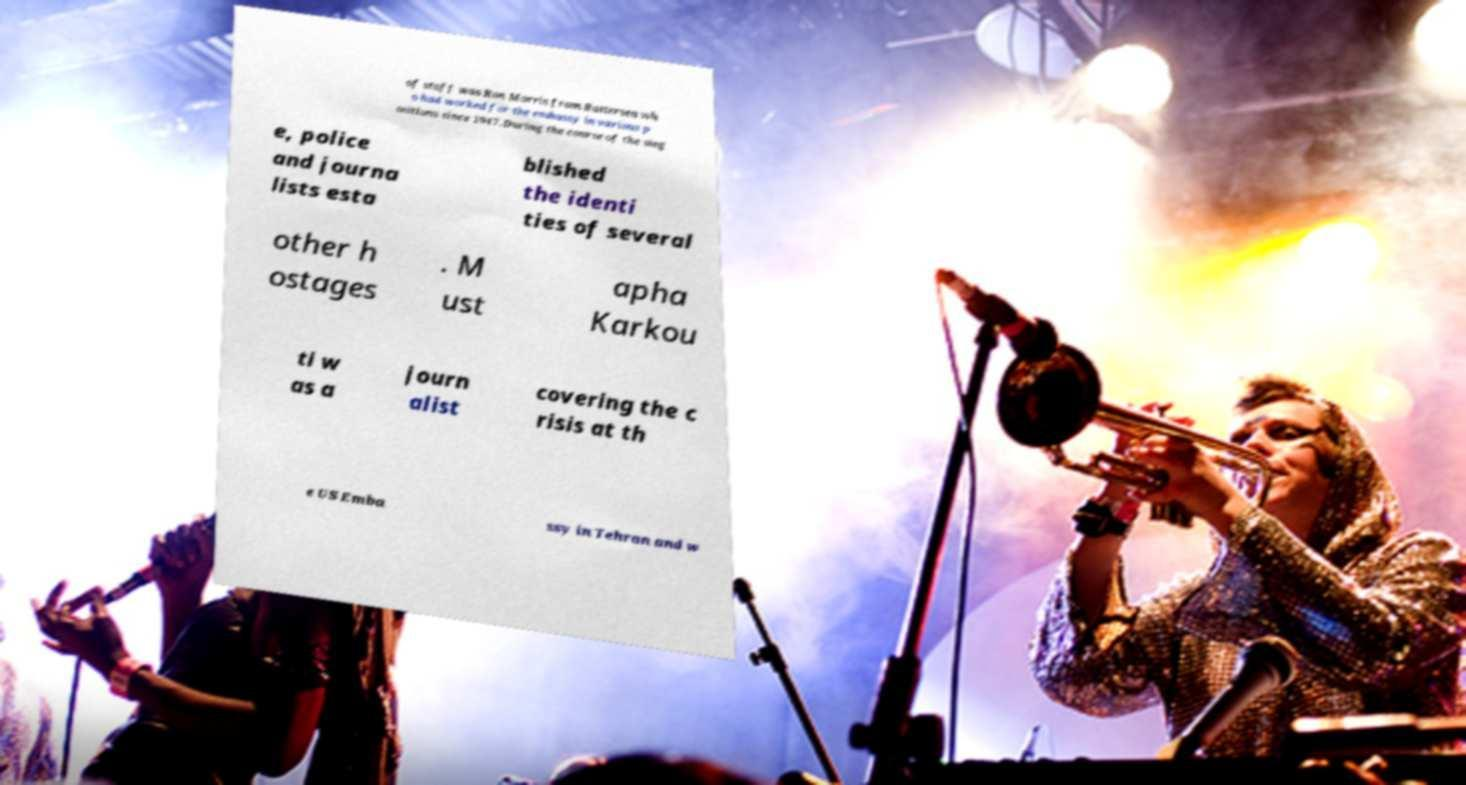Can you read and provide the text displayed in the image?This photo seems to have some interesting text. Can you extract and type it out for me? of staff was Ron Morris from Battersea wh o had worked for the embassy in various p ositions since 1947.During the course of the sieg e, police and journa lists esta blished the identi ties of several other h ostages . M ust apha Karkou ti w as a journ alist covering the c risis at th e US Emba ssy in Tehran and w 